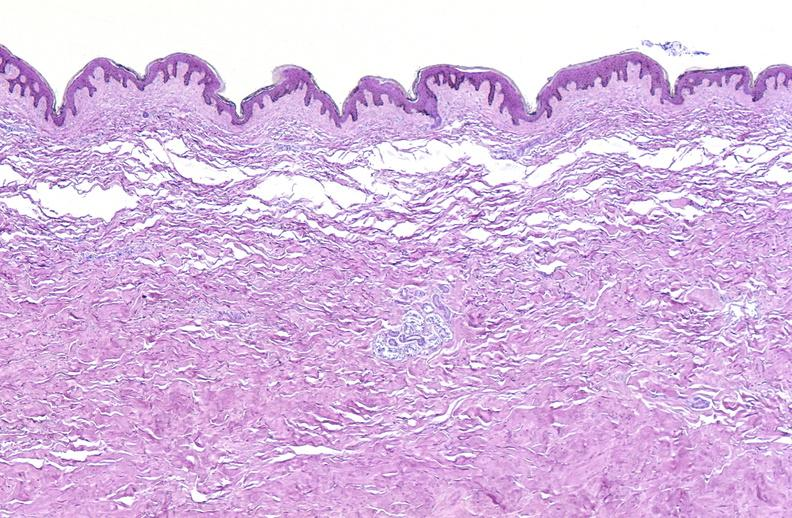where is this?
Answer the question using a single word or phrase. Skin 